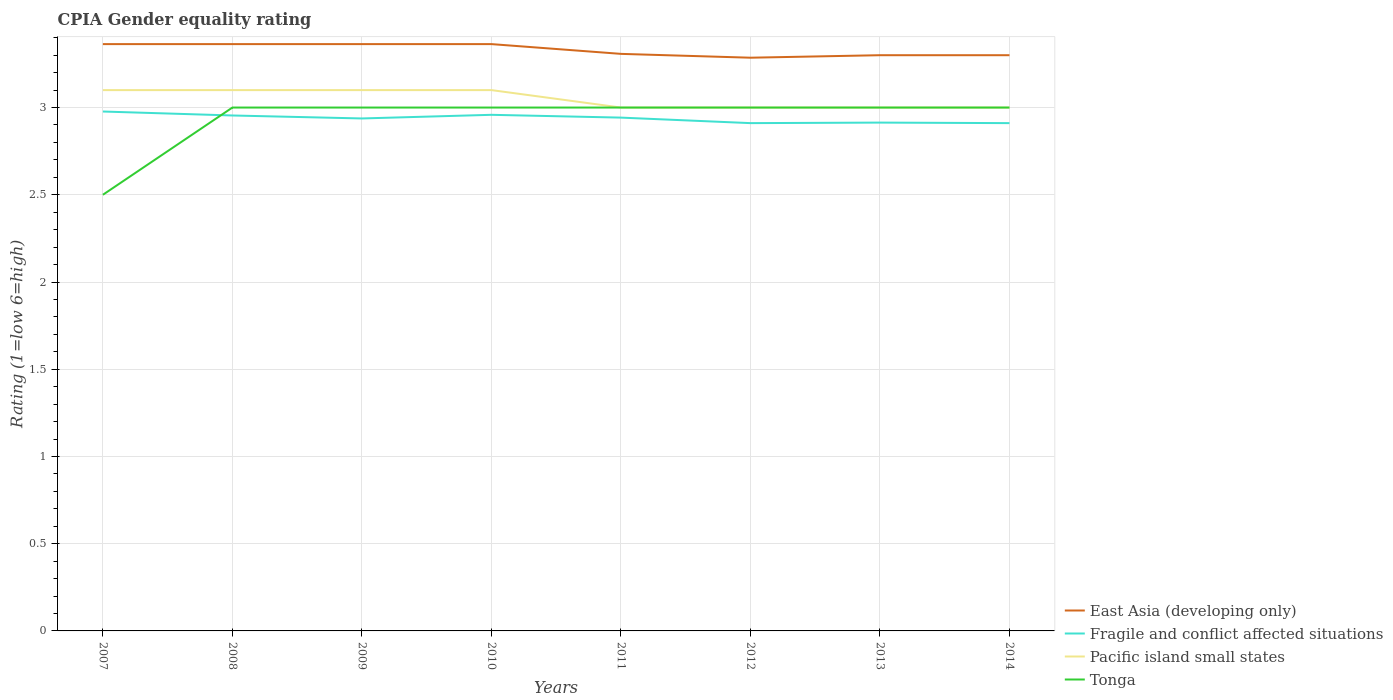How many different coloured lines are there?
Keep it short and to the point. 4. Does the line corresponding to Fragile and conflict affected situations intersect with the line corresponding to East Asia (developing only)?
Your response must be concise. No. Is the number of lines equal to the number of legend labels?
Keep it short and to the point. Yes. Across all years, what is the maximum CPIA rating in Fragile and conflict affected situations?
Give a very brief answer. 2.91. In which year was the CPIA rating in Fragile and conflict affected situations maximum?
Provide a short and direct response. 2012. What is the total CPIA rating in Fragile and conflict affected situations in the graph?
Ensure brevity in your answer.  0.07. What is the difference between the highest and the second highest CPIA rating in Pacific island small states?
Make the answer very short. 0.1. Is the CPIA rating in Pacific island small states strictly greater than the CPIA rating in Tonga over the years?
Offer a terse response. No. How many years are there in the graph?
Offer a terse response. 8. How many legend labels are there?
Provide a succinct answer. 4. What is the title of the graph?
Your response must be concise. CPIA Gender equality rating. What is the label or title of the Y-axis?
Offer a terse response. Rating (1=low 6=high). What is the Rating (1=low 6=high) of East Asia (developing only) in 2007?
Offer a terse response. 3.36. What is the Rating (1=low 6=high) in Fragile and conflict affected situations in 2007?
Make the answer very short. 2.98. What is the Rating (1=low 6=high) in Tonga in 2007?
Provide a short and direct response. 2.5. What is the Rating (1=low 6=high) of East Asia (developing only) in 2008?
Offer a very short reply. 3.36. What is the Rating (1=low 6=high) in Fragile and conflict affected situations in 2008?
Your response must be concise. 2.95. What is the Rating (1=low 6=high) in Pacific island small states in 2008?
Ensure brevity in your answer.  3.1. What is the Rating (1=low 6=high) of East Asia (developing only) in 2009?
Make the answer very short. 3.36. What is the Rating (1=low 6=high) of Fragile and conflict affected situations in 2009?
Keep it short and to the point. 2.94. What is the Rating (1=low 6=high) of Pacific island small states in 2009?
Ensure brevity in your answer.  3.1. What is the Rating (1=low 6=high) of Tonga in 2009?
Give a very brief answer. 3. What is the Rating (1=low 6=high) of East Asia (developing only) in 2010?
Provide a succinct answer. 3.36. What is the Rating (1=low 6=high) in Fragile and conflict affected situations in 2010?
Make the answer very short. 2.96. What is the Rating (1=low 6=high) in East Asia (developing only) in 2011?
Give a very brief answer. 3.31. What is the Rating (1=low 6=high) of Fragile and conflict affected situations in 2011?
Provide a short and direct response. 2.94. What is the Rating (1=low 6=high) of East Asia (developing only) in 2012?
Ensure brevity in your answer.  3.29. What is the Rating (1=low 6=high) in Fragile and conflict affected situations in 2012?
Provide a succinct answer. 2.91. What is the Rating (1=low 6=high) of East Asia (developing only) in 2013?
Offer a very short reply. 3.3. What is the Rating (1=low 6=high) of Fragile and conflict affected situations in 2013?
Ensure brevity in your answer.  2.91. What is the Rating (1=low 6=high) of Pacific island small states in 2013?
Make the answer very short. 3. What is the Rating (1=low 6=high) in East Asia (developing only) in 2014?
Your answer should be very brief. 3.3. What is the Rating (1=low 6=high) of Fragile and conflict affected situations in 2014?
Your answer should be very brief. 2.91. What is the Rating (1=low 6=high) of Pacific island small states in 2014?
Offer a terse response. 3. Across all years, what is the maximum Rating (1=low 6=high) in East Asia (developing only)?
Your answer should be compact. 3.36. Across all years, what is the maximum Rating (1=low 6=high) of Fragile and conflict affected situations?
Keep it short and to the point. 2.98. Across all years, what is the maximum Rating (1=low 6=high) in Pacific island small states?
Make the answer very short. 3.1. Across all years, what is the maximum Rating (1=low 6=high) in Tonga?
Your answer should be very brief. 3. Across all years, what is the minimum Rating (1=low 6=high) in East Asia (developing only)?
Provide a succinct answer. 3.29. Across all years, what is the minimum Rating (1=low 6=high) of Fragile and conflict affected situations?
Give a very brief answer. 2.91. Across all years, what is the minimum Rating (1=low 6=high) in Pacific island small states?
Offer a terse response. 3. What is the total Rating (1=low 6=high) in East Asia (developing only) in the graph?
Provide a short and direct response. 26.65. What is the total Rating (1=low 6=high) of Fragile and conflict affected situations in the graph?
Your answer should be very brief. 23.51. What is the total Rating (1=low 6=high) in Pacific island small states in the graph?
Offer a very short reply. 24.4. What is the difference between the Rating (1=low 6=high) of East Asia (developing only) in 2007 and that in 2008?
Provide a succinct answer. 0. What is the difference between the Rating (1=low 6=high) in Fragile and conflict affected situations in 2007 and that in 2008?
Offer a very short reply. 0.02. What is the difference between the Rating (1=low 6=high) in Tonga in 2007 and that in 2008?
Your answer should be very brief. -0.5. What is the difference between the Rating (1=low 6=high) in East Asia (developing only) in 2007 and that in 2009?
Give a very brief answer. 0. What is the difference between the Rating (1=low 6=high) of Fragile and conflict affected situations in 2007 and that in 2009?
Offer a terse response. 0.04. What is the difference between the Rating (1=low 6=high) of Fragile and conflict affected situations in 2007 and that in 2010?
Provide a short and direct response. 0.02. What is the difference between the Rating (1=low 6=high) in Tonga in 2007 and that in 2010?
Offer a very short reply. -0.5. What is the difference between the Rating (1=low 6=high) in East Asia (developing only) in 2007 and that in 2011?
Make the answer very short. 0.06. What is the difference between the Rating (1=low 6=high) of Fragile and conflict affected situations in 2007 and that in 2011?
Ensure brevity in your answer.  0.04. What is the difference between the Rating (1=low 6=high) in Tonga in 2007 and that in 2011?
Ensure brevity in your answer.  -0.5. What is the difference between the Rating (1=low 6=high) in East Asia (developing only) in 2007 and that in 2012?
Ensure brevity in your answer.  0.08. What is the difference between the Rating (1=low 6=high) of Fragile and conflict affected situations in 2007 and that in 2012?
Your answer should be very brief. 0.07. What is the difference between the Rating (1=low 6=high) of Tonga in 2007 and that in 2012?
Ensure brevity in your answer.  -0.5. What is the difference between the Rating (1=low 6=high) of East Asia (developing only) in 2007 and that in 2013?
Your answer should be very brief. 0.06. What is the difference between the Rating (1=low 6=high) in Fragile and conflict affected situations in 2007 and that in 2013?
Your response must be concise. 0.06. What is the difference between the Rating (1=low 6=high) in Pacific island small states in 2007 and that in 2013?
Offer a very short reply. 0.1. What is the difference between the Rating (1=low 6=high) of East Asia (developing only) in 2007 and that in 2014?
Provide a succinct answer. 0.06. What is the difference between the Rating (1=low 6=high) of Fragile and conflict affected situations in 2007 and that in 2014?
Provide a succinct answer. 0.07. What is the difference between the Rating (1=low 6=high) in Pacific island small states in 2007 and that in 2014?
Offer a terse response. 0.1. What is the difference between the Rating (1=low 6=high) in East Asia (developing only) in 2008 and that in 2009?
Your answer should be compact. 0. What is the difference between the Rating (1=low 6=high) of Fragile and conflict affected situations in 2008 and that in 2009?
Your answer should be compact. 0.02. What is the difference between the Rating (1=low 6=high) in Tonga in 2008 and that in 2009?
Give a very brief answer. 0. What is the difference between the Rating (1=low 6=high) in East Asia (developing only) in 2008 and that in 2010?
Your response must be concise. 0. What is the difference between the Rating (1=low 6=high) of Fragile and conflict affected situations in 2008 and that in 2010?
Offer a very short reply. -0. What is the difference between the Rating (1=low 6=high) in Pacific island small states in 2008 and that in 2010?
Your response must be concise. 0. What is the difference between the Rating (1=low 6=high) in East Asia (developing only) in 2008 and that in 2011?
Keep it short and to the point. 0.06. What is the difference between the Rating (1=low 6=high) of Fragile and conflict affected situations in 2008 and that in 2011?
Your response must be concise. 0.01. What is the difference between the Rating (1=low 6=high) in Tonga in 2008 and that in 2011?
Ensure brevity in your answer.  0. What is the difference between the Rating (1=low 6=high) in East Asia (developing only) in 2008 and that in 2012?
Ensure brevity in your answer.  0.08. What is the difference between the Rating (1=low 6=high) in Fragile and conflict affected situations in 2008 and that in 2012?
Your answer should be very brief. 0.04. What is the difference between the Rating (1=low 6=high) of East Asia (developing only) in 2008 and that in 2013?
Your answer should be compact. 0.06. What is the difference between the Rating (1=low 6=high) of Fragile and conflict affected situations in 2008 and that in 2013?
Your answer should be very brief. 0.04. What is the difference between the Rating (1=low 6=high) in Pacific island small states in 2008 and that in 2013?
Offer a very short reply. 0.1. What is the difference between the Rating (1=low 6=high) of East Asia (developing only) in 2008 and that in 2014?
Ensure brevity in your answer.  0.06. What is the difference between the Rating (1=low 6=high) of Fragile and conflict affected situations in 2008 and that in 2014?
Give a very brief answer. 0.04. What is the difference between the Rating (1=low 6=high) of Pacific island small states in 2008 and that in 2014?
Your answer should be very brief. 0.1. What is the difference between the Rating (1=low 6=high) of Fragile and conflict affected situations in 2009 and that in 2010?
Provide a short and direct response. -0.02. What is the difference between the Rating (1=low 6=high) in Tonga in 2009 and that in 2010?
Your response must be concise. 0. What is the difference between the Rating (1=low 6=high) in East Asia (developing only) in 2009 and that in 2011?
Ensure brevity in your answer.  0.06. What is the difference between the Rating (1=low 6=high) of Fragile and conflict affected situations in 2009 and that in 2011?
Make the answer very short. -0. What is the difference between the Rating (1=low 6=high) of Pacific island small states in 2009 and that in 2011?
Your response must be concise. 0.1. What is the difference between the Rating (1=low 6=high) in Tonga in 2009 and that in 2011?
Your answer should be compact. 0. What is the difference between the Rating (1=low 6=high) in East Asia (developing only) in 2009 and that in 2012?
Your response must be concise. 0.08. What is the difference between the Rating (1=low 6=high) of Fragile and conflict affected situations in 2009 and that in 2012?
Provide a succinct answer. 0.03. What is the difference between the Rating (1=low 6=high) of Tonga in 2009 and that in 2012?
Make the answer very short. 0. What is the difference between the Rating (1=low 6=high) in East Asia (developing only) in 2009 and that in 2013?
Offer a terse response. 0.06. What is the difference between the Rating (1=low 6=high) in Fragile and conflict affected situations in 2009 and that in 2013?
Your answer should be compact. 0.02. What is the difference between the Rating (1=low 6=high) in East Asia (developing only) in 2009 and that in 2014?
Ensure brevity in your answer.  0.06. What is the difference between the Rating (1=low 6=high) of Fragile and conflict affected situations in 2009 and that in 2014?
Make the answer very short. 0.03. What is the difference between the Rating (1=low 6=high) of Tonga in 2009 and that in 2014?
Ensure brevity in your answer.  0. What is the difference between the Rating (1=low 6=high) of East Asia (developing only) in 2010 and that in 2011?
Your answer should be compact. 0.06. What is the difference between the Rating (1=low 6=high) in Fragile and conflict affected situations in 2010 and that in 2011?
Offer a terse response. 0.02. What is the difference between the Rating (1=low 6=high) in Pacific island small states in 2010 and that in 2011?
Provide a short and direct response. 0.1. What is the difference between the Rating (1=low 6=high) of Tonga in 2010 and that in 2011?
Your response must be concise. 0. What is the difference between the Rating (1=low 6=high) of East Asia (developing only) in 2010 and that in 2012?
Offer a very short reply. 0.08. What is the difference between the Rating (1=low 6=high) in Fragile and conflict affected situations in 2010 and that in 2012?
Your answer should be very brief. 0.05. What is the difference between the Rating (1=low 6=high) of Tonga in 2010 and that in 2012?
Give a very brief answer. 0. What is the difference between the Rating (1=low 6=high) of East Asia (developing only) in 2010 and that in 2013?
Provide a short and direct response. 0.06. What is the difference between the Rating (1=low 6=high) of Fragile and conflict affected situations in 2010 and that in 2013?
Your answer should be very brief. 0.04. What is the difference between the Rating (1=low 6=high) in East Asia (developing only) in 2010 and that in 2014?
Your response must be concise. 0.06. What is the difference between the Rating (1=low 6=high) in Fragile and conflict affected situations in 2010 and that in 2014?
Offer a terse response. 0.05. What is the difference between the Rating (1=low 6=high) in Pacific island small states in 2010 and that in 2014?
Offer a terse response. 0.1. What is the difference between the Rating (1=low 6=high) of Tonga in 2010 and that in 2014?
Your answer should be compact. 0. What is the difference between the Rating (1=low 6=high) in East Asia (developing only) in 2011 and that in 2012?
Your response must be concise. 0.02. What is the difference between the Rating (1=low 6=high) of Fragile and conflict affected situations in 2011 and that in 2012?
Ensure brevity in your answer.  0.03. What is the difference between the Rating (1=low 6=high) of Pacific island small states in 2011 and that in 2012?
Your answer should be compact. 0. What is the difference between the Rating (1=low 6=high) in Tonga in 2011 and that in 2012?
Offer a terse response. 0. What is the difference between the Rating (1=low 6=high) in East Asia (developing only) in 2011 and that in 2013?
Provide a short and direct response. 0.01. What is the difference between the Rating (1=low 6=high) in Fragile and conflict affected situations in 2011 and that in 2013?
Your answer should be very brief. 0.03. What is the difference between the Rating (1=low 6=high) in Pacific island small states in 2011 and that in 2013?
Your response must be concise. 0. What is the difference between the Rating (1=low 6=high) of East Asia (developing only) in 2011 and that in 2014?
Provide a short and direct response. 0.01. What is the difference between the Rating (1=low 6=high) in Fragile and conflict affected situations in 2011 and that in 2014?
Make the answer very short. 0.03. What is the difference between the Rating (1=low 6=high) in East Asia (developing only) in 2012 and that in 2013?
Keep it short and to the point. -0.01. What is the difference between the Rating (1=low 6=high) in Fragile and conflict affected situations in 2012 and that in 2013?
Keep it short and to the point. -0. What is the difference between the Rating (1=low 6=high) in Pacific island small states in 2012 and that in 2013?
Your response must be concise. 0. What is the difference between the Rating (1=low 6=high) of East Asia (developing only) in 2012 and that in 2014?
Provide a short and direct response. -0.01. What is the difference between the Rating (1=low 6=high) in Fragile and conflict affected situations in 2012 and that in 2014?
Your response must be concise. 0. What is the difference between the Rating (1=low 6=high) of Pacific island small states in 2012 and that in 2014?
Your response must be concise. 0. What is the difference between the Rating (1=low 6=high) of Fragile and conflict affected situations in 2013 and that in 2014?
Your answer should be compact. 0. What is the difference between the Rating (1=low 6=high) in Tonga in 2013 and that in 2014?
Keep it short and to the point. 0. What is the difference between the Rating (1=low 6=high) in East Asia (developing only) in 2007 and the Rating (1=low 6=high) in Fragile and conflict affected situations in 2008?
Offer a very short reply. 0.41. What is the difference between the Rating (1=low 6=high) of East Asia (developing only) in 2007 and the Rating (1=low 6=high) of Pacific island small states in 2008?
Your answer should be compact. 0.26. What is the difference between the Rating (1=low 6=high) in East Asia (developing only) in 2007 and the Rating (1=low 6=high) in Tonga in 2008?
Offer a terse response. 0.36. What is the difference between the Rating (1=low 6=high) of Fragile and conflict affected situations in 2007 and the Rating (1=low 6=high) of Pacific island small states in 2008?
Give a very brief answer. -0.12. What is the difference between the Rating (1=low 6=high) of Fragile and conflict affected situations in 2007 and the Rating (1=low 6=high) of Tonga in 2008?
Ensure brevity in your answer.  -0.02. What is the difference between the Rating (1=low 6=high) in East Asia (developing only) in 2007 and the Rating (1=low 6=high) in Fragile and conflict affected situations in 2009?
Provide a short and direct response. 0.43. What is the difference between the Rating (1=low 6=high) in East Asia (developing only) in 2007 and the Rating (1=low 6=high) in Pacific island small states in 2009?
Offer a terse response. 0.26. What is the difference between the Rating (1=low 6=high) in East Asia (developing only) in 2007 and the Rating (1=low 6=high) in Tonga in 2009?
Provide a short and direct response. 0.36. What is the difference between the Rating (1=low 6=high) in Fragile and conflict affected situations in 2007 and the Rating (1=low 6=high) in Pacific island small states in 2009?
Offer a terse response. -0.12. What is the difference between the Rating (1=low 6=high) in Fragile and conflict affected situations in 2007 and the Rating (1=low 6=high) in Tonga in 2009?
Make the answer very short. -0.02. What is the difference between the Rating (1=low 6=high) of East Asia (developing only) in 2007 and the Rating (1=low 6=high) of Fragile and conflict affected situations in 2010?
Give a very brief answer. 0.41. What is the difference between the Rating (1=low 6=high) in East Asia (developing only) in 2007 and the Rating (1=low 6=high) in Pacific island small states in 2010?
Your response must be concise. 0.26. What is the difference between the Rating (1=low 6=high) of East Asia (developing only) in 2007 and the Rating (1=low 6=high) of Tonga in 2010?
Keep it short and to the point. 0.36. What is the difference between the Rating (1=low 6=high) of Fragile and conflict affected situations in 2007 and the Rating (1=low 6=high) of Pacific island small states in 2010?
Make the answer very short. -0.12. What is the difference between the Rating (1=low 6=high) of Fragile and conflict affected situations in 2007 and the Rating (1=low 6=high) of Tonga in 2010?
Provide a short and direct response. -0.02. What is the difference between the Rating (1=low 6=high) in East Asia (developing only) in 2007 and the Rating (1=low 6=high) in Fragile and conflict affected situations in 2011?
Your response must be concise. 0.42. What is the difference between the Rating (1=low 6=high) of East Asia (developing only) in 2007 and the Rating (1=low 6=high) of Pacific island small states in 2011?
Ensure brevity in your answer.  0.36. What is the difference between the Rating (1=low 6=high) in East Asia (developing only) in 2007 and the Rating (1=low 6=high) in Tonga in 2011?
Offer a very short reply. 0.36. What is the difference between the Rating (1=low 6=high) of Fragile and conflict affected situations in 2007 and the Rating (1=low 6=high) of Pacific island small states in 2011?
Offer a terse response. -0.02. What is the difference between the Rating (1=low 6=high) in Fragile and conflict affected situations in 2007 and the Rating (1=low 6=high) in Tonga in 2011?
Give a very brief answer. -0.02. What is the difference between the Rating (1=low 6=high) of Pacific island small states in 2007 and the Rating (1=low 6=high) of Tonga in 2011?
Offer a terse response. 0.1. What is the difference between the Rating (1=low 6=high) of East Asia (developing only) in 2007 and the Rating (1=low 6=high) of Fragile and conflict affected situations in 2012?
Make the answer very short. 0.45. What is the difference between the Rating (1=low 6=high) in East Asia (developing only) in 2007 and the Rating (1=low 6=high) in Pacific island small states in 2012?
Offer a terse response. 0.36. What is the difference between the Rating (1=low 6=high) of East Asia (developing only) in 2007 and the Rating (1=low 6=high) of Tonga in 2012?
Keep it short and to the point. 0.36. What is the difference between the Rating (1=low 6=high) of Fragile and conflict affected situations in 2007 and the Rating (1=low 6=high) of Pacific island small states in 2012?
Offer a very short reply. -0.02. What is the difference between the Rating (1=low 6=high) of Fragile and conflict affected situations in 2007 and the Rating (1=low 6=high) of Tonga in 2012?
Keep it short and to the point. -0.02. What is the difference between the Rating (1=low 6=high) of Pacific island small states in 2007 and the Rating (1=low 6=high) of Tonga in 2012?
Your answer should be very brief. 0.1. What is the difference between the Rating (1=low 6=high) in East Asia (developing only) in 2007 and the Rating (1=low 6=high) in Fragile and conflict affected situations in 2013?
Ensure brevity in your answer.  0.45. What is the difference between the Rating (1=low 6=high) of East Asia (developing only) in 2007 and the Rating (1=low 6=high) of Pacific island small states in 2013?
Make the answer very short. 0.36. What is the difference between the Rating (1=low 6=high) of East Asia (developing only) in 2007 and the Rating (1=low 6=high) of Tonga in 2013?
Offer a very short reply. 0.36. What is the difference between the Rating (1=low 6=high) in Fragile and conflict affected situations in 2007 and the Rating (1=low 6=high) in Pacific island small states in 2013?
Provide a succinct answer. -0.02. What is the difference between the Rating (1=low 6=high) in Fragile and conflict affected situations in 2007 and the Rating (1=low 6=high) in Tonga in 2013?
Provide a short and direct response. -0.02. What is the difference between the Rating (1=low 6=high) in Pacific island small states in 2007 and the Rating (1=low 6=high) in Tonga in 2013?
Your answer should be compact. 0.1. What is the difference between the Rating (1=low 6=high) of East Asia (developing only) in 2007 and the Rating (1=low 6=high) of Fragile and conflict affected situations in 2014?
Offer a very short reply. 0.45. What is the difference between the Rating (1=low 6=high) in East Asia (developing only) in 2007 and the Rating (1=low 6=high) in Pacific island small states in 2014?
Your answer should be compact. 0.36. What is the difference between the Rating (1=low 6=high) of East Asia (developing only) in 2007 and the Rating (1=low 6=high) of Tonga in 2014?
Offer a terse response. 0.36. What is the difference between the Rating (1=low 6=high) of Fragile and conflict affected situations in 2007 and the Rating (1=low 6=high) of Pacific island small states in 2014?
Make the answer very short. -0.02. What is the difference between the Rating (1=low 6=high) in Fragile and conflict affected situations in 2007 and the Rating (1=low 6=high) in Tonga in 2014?
Offer a terse response. -0.02. What is the difference between the Rating (1=low 6=high) in Pacific island small states in 2007 and the Rating (1=low 6=high) in Tonga in 2014?
Make the answer very short. 0.1. What is the difference between the Rating (1=low 6=high) of East Asia (developing only) in 2008 and the Rating (1=low 6=high) of Fragile and conflict affected situations in 2009?
Provide a short and direct response. 0.43. What is the difference between the Rating (1=low 6=high) in East Asia (developing only) in 2008 and the Rating (1=low 6=high) in Pacific island small states in 2009?
Your answer should be compact. 0.26. What is the difference between the Rating (1=low 6=high) in East Asia (developing only) in 2008 and the Rating (1=low 6=high) in Tonga in 2009?
Ensure brevity in your answer.  0.36. What is the difference between the Rating (1=low 6=high) in Fragile and conflict affected situations in 2008 and the Rating (1=low 6=high) in Pacific island small states in 2009?
Your answer should be very brief. -0.15. What is the difference between the Rating (1=low 6=high) in Fragile and conflict affected situations in 2008 and the Rating (1=low 6=high) in Tonga in 2009?
Your response must be concise. -0.05. What is the difference between the Rating (1=low 6=high) in East Asia (developing only) in 2008 and the Rating (1=low 6=high) in Fragile and conflict affected situations in 2010?
Give a very brief answer. 0.41. What is the difference between the Rating (1=low 6=high) in East Asia (developing only) in 2008 and the Rating (1=low 6=high) in Pacific island small states in 2010?
Provide a succinct answer. 0.26. What is the difference between the Rating (1=low 6=high) in East Asia (developing only) in 2008 and the Rating (1=low 6=high) in Tonga in 2010?
Offer a terse response. 0.36. What is the difference between the Rating (1=low 6=high) of Fragile and conflict affected situations in 2008 and the Rating (1=low 6=high) of Pacific island small states in 2010?
Offer a very short reply. -0.15. What is the difference between the Rating (1=low 6=high) in Fragile and conflict affected situations in 2008 and the Rating (1=low 6=high) in Tonga in 2010?
Your answer should be compact. -0.05. What is the difference between the Rating (1=low 6=high) of East Asia (developing only) in 2008 and the Rating (1=low 6=high) of Fragile and conflict affected situations in 2011?
Offer a terse response. 0.42. What is the difference between the Rating (1=low 6=high) of East Asia (developing only) in 2008 and the Rating (1=low 6=high) of Pacific island small states in 2011?
Your answer should be compact. 0.36. What is the difference between the Rating (1=low 6=high) in East Asia (developing only) in 2008 and the Rating (1=low 6=high) in Tonga in 2011?
Make the answer very short. 0.36. What is the difference between the Rating (1=low 6=high) in Fragile and conflict affected situations in 2008 and the Rating (1=low 6=high) in Pacific island small states in 2011?
Make the answer very short. -0.05. What is the difference between the Rating (1=low 6=high) of Fragile and conflict affected situations in 2008 and the Rating (1=low 6=high) of Tonga in 2011?
Give a very brief answer. -0.05. What is the difference between the Rating (1=low 6=high) in East Asia (developing only) in 2008 and the Rating (1=low 6=high) in Fragile and conflict affected situations in 2012?
Make the answer very short. 0.45. What is the difference between the Rating (1=low 6=high) in East Asia (developing only) in 2008 and the Rating (1=low 6=high) in Pacific island small states in 2012?
Offer a very short reply. 0.36. What is the difference between the Rating (1=low 6=high) in East Asia (developing only) in 2008 and the Rating (1=low 6=high) in Tonga in 2012?
Ensure brevity in your answer.  0.36. What is the difference between the Rating (1=low 6=high) in Fragile and conflict affected situations in 2008 and the Rating (1=low 6=high) in Pacific island small states in 2012?
Your answer should be compact. -0.05. What is the difference between the Rating (1=low 6=high) of Fragile and conflict affected situations in 2008 and the Rating (1=low 6=high) of Tonga in 2012?
Your response must be concise. -0.05. What is the difference between the Rating (1=low 6=high) of Pacific island small states in 2008 and the Rating (1=low 6=high) of Tonga in 2012?
Offer a very short reply. 0.1. What is the difference between the Rating (1=low 6=high) of East Asia (developing only) in 2008 and the Rating (1=low 6=high) of Fragile and conflict affected situations in 2013?
Give a very brief answer. 0.45. What is the difference between the Rating (1=low 6=high) of East Asia (developing only) in 2008 and the Rating (1=low 6=high) of Pacific island small states in 2013?
Make the answer very short. 0.36. What is the difference between the Rating (1=low 6=high) of East Asia (developing only) in 2008 and the Rating (1=low 6=high) of Tonga in 2013?
Your answer should be very brief. 0.36. What is the difference between the Rating (1=low 6=high) of Fragile and conflict affected situations in 2008 and the Rating (1=low 6=high) of Pacific island small states in 2013?
Your response must be concise. -0.05. What is the difference between the Rating (1=low 6=high) in Fragile and conflict affected situations in 2008 and the Rating (1=low 6=high) in Tonga in 2013?
Provide a succinct answer. -0.05. What is the difference between the Rating (1=low 6=high) of East Asia (developing only) in 2008 and the Rating (1=low 6=high) of Fragile and conflict affected situations in 2014?
Offer a very short reply. 0.45. What is the difference between the Rating (1=low 6=high) of East Asia (developing only) in 2008 and the Rating (1=low 6=high) of Pacific island small states in 2014?
Your answer should be compact. 0.36. What is the difference between the Rating (1=low 6=high) in East Asia (developing only) in 2008 and the Rating (1=low 6=high) in Tonga in 2014?
Offer a very short reply. 0.36. What is the difference between the Rating (1=low 6=high) in Fragile and conflict affected situations in 2008 and the Rating (1=low 6=high) in Pacific island small states in 2014?
Offer a very short reply. -0.05. What is the difference between the Rating (1=low 6=high) of Fragile and conflict affected situations in 2008 and the Rating (1=low 6=high) of Tonga in 2014?
Ensure brevity in your answer.  -0.05. What is the difference between the Rating (1=low 6=high) in Pacific island small states in 2008 and the Rating (1=low 6=high) in Tonga in 2014?
Make the answer very short. 0.1. What is the difference between the Rating (1=low 6=high) of East Asia (developing only) in 2009 and the Rating (1=low 6=high) of Fragile and conflict affected situations in 2010?
Provide a succinct answer. 0.41. What is the difference between the Rating (1=low 6=high) in East Asia (developing only) in 2009 and the Rating (1=low 6=high) in Pacific island small states in 2010?
Ensure brevity in your answer.  0.26. What is the difference between the Rating (1=low 6=high) of East Asia (developing only) in 2009 and the Rating (1=low 6=high) of Tonga in 2010?
Keep it short and to the point. 0.36. What is the difference between the Rating (1=low 6=high) of Fragile and conflict affected situations in 2009 and the Rating (1=low 6=high) of Pacific island small states in 2010?
Keep it short and to the point. -0.16. What is the difference between the Rating (1=low 6=high) in Fragile and conflict affected situations in 2009 and the Rating (1=low 6=high) in Tonga in 2010?
Your response must be concise. -0.06. What is the difference between the Rating (1=low 6=high) in East Asia (developing only) in 2009 and the Rating (1=low 6=high) in Fragile and conflict affected situations in 2011?
Provide a short and direct response. 0.42. What is the difference between the Rating (1=low 6=high) of East Asia (developing only) in 2009 and the Rating (1=low 6=high) of Pacific island small states in 2011?
Give a very brief answer. 0.36. What is the difference between the Rating (1=low 6=high) of East Asia (developing only) in 2009 and the Rating (1=low 6=high) of Tonga in 2011?
Your response must be concise. 0.36. What is the difference between the Rating (1=low 6=high) in Fragile and conflict affected situations in 2009 and the Rating (1=low 6=high) in Pacific island small states in 2011?
Provide a succinct answer. -0.06. What is the difference between the Rating (1=low 6=high) in Fragile and conflict affected situations in 2009 and the Rating (1=low 6=high) in Tonga in 2011?
Ensure brevity in your answer.  -0.06. What is the difference between the Rating (1=low 6=high) in East Asia (developing only) in 2009 and the Rating (1=low 6=high) in Fragile and conflict affected situations in 2012?
Provide a succinct answer. 0.45. What is the difference between the Rating (1=low 6=high) in East Asia (developing only) in 2009 and the Rating (1=low 6=high) in Pacific island small states in 2012?
Provide a succinct answer. 0.36. What is the difference between the Rating (1=low 6=high) in East Asia (developing only) in 2009 and the Rating (1=low 6=high) in Tonga in 2012?
Provide a succinct answer. 0.36. What is the difference between the Rating (1=low 6=high) of Fragile and conflict affected situations in 2009 and the Rating (1=low 6=high) of Pacific island small states in 2012?
Your answer should be very brief. -0.06. What is the difference between the Rating (1=low 6=high) in Fragile and conflict affected situations in 2009 and the Rating (1=low 6=high) in Tonga in 2012?
Make the answer very short. -0.06. What is the difference between the Rating (1=low 6=high) in East Asia (developing only) in 2009 and the Rating (1=low 6=high) in Fragile and conflict affected situations in 2013?
Give a very brief answer. 0.45. What is the difference between the Rating (1=low 6=high) of East Asia (developing only) in 2009 and the Rating (1=low 6=high) of Pacific island small states in 2013?
Offer a very short reply. 0.36. What is the difference between the Rating (1=low 6=high) in East Asia (developing only) in 2009 and the Rating (1=low 6=high) in Tonga in 2013?
Your answer should be very brief. 0.36. What is the difference between the Rating (1=low 6=high) of Fragile and conflict affected situations in 2009 and the Rating (1=low 6=high) of Pacific island small states in 2013?
Make the answer very short. -0.06. What is the difference between the Rating (1=low 6=high) in Fragile and conflict affected situations in 2009 and the Rating (1=low 6=high) in Tonga in 2013?
Offer a very short reply. -0.06. What is the difference between the Rating (1=low 6=high) in Pacific island small states in 2009 and the Rating (1=low 6=high) in Tonga in 2013?
Keep it short and to the point. 0.1. What is the difference between the Rating (1=low 6=high) of East Asia (developing only) in 2009 and the Rating (1=low 6=high) of Fragile and conflict affected situations in 2014?
Keep it short and to the point. 0.45. What is the difference between the Rating (1=low 6=high) of East Asia (developing only) in 2009 and the Rating (1=low 6=high) of Pacific island small states in 2014?
Provide a succinct answer. 0.36. What is the difference between the Rating (1=low 6=high) of East Asia (developing only) in 2009 and the Rating (1=low 6=high) of Tonga in 2014?
Your answer should be very brief. 0.36. What is the difference between the Rating (1=low 6=high) in Fragile and conflict affected situations in 2009 and the Rating (1=low 6=high) in Pacific island small states in 2014?
Offer a very short reply. -0.06. What is the difference between the Rating (1=low 6=high) in Fragile and conflict affected situations in 2009 and the Rating (1=low 6=high) in Tonga in 2014?
Ensure brevity in your answer.  -0.06. What is the difference between the Rating (1=low 6=high) of East Asia (developing only) in 2010 and the Rating (1=low 6=high) of Fragile and conflict affected situations in 2011?
Provide a short and direct response. 0.42. What is the difference between the Rating (1=low 6=high) in East Asia (developing only) in 2010 and the Rating (1=low 6=high) in Pacific island small states in 2011?
Your response must be concise. 0.36. What is the difference between the Rating (1=low 6=high) in East Asia (developing only) in 2010 and the Rating (1=low 6=high) in Tonga in 2011?
Provide a succinct answer. 0.36. What is the difference between the Rating (1=low 6=high) in Fragile and conflict affected situations in 2010 and the Rating (1=low 6=high) in Pacific island small states in 2011?
Offer a terse response. -0.04. What is the difference between the Rating (1=low 6=high) of Fragile and conflict affected situations in 2010 and the Rating (1=low 6=high) of Tonga in 2011?
Provide a short and direct response. -0.04. What is the difference between the Rating (1=low 6=high) of East Asia (developing only) in 2010 and the Rating (1=low 6=high) of Fragile and conflict affected situations in 2012?
Offer a terse response. 0.45. What is the difference between the Rating (1=low 6=high) in East Asia (developing only) in 2010 and the Rating (1=low 6=high) in Pacific island small states in 2012?
Provide a short and direct response. 0.36. What is the difference between the Rating (1=low 6=high) of East Asia (developing only) in 2010 and the Rating (1=low 6=high) of Tonga in 2012?
Offer a very short reply. 0.36. What is the difference between the Rating (1=low 6=high) of Fragile and conflict affected situations in 2010 and the Rating (1=low 6=high) of Pacific island small states in 2012?
Your answer should be very brief. -0.04. What is the difference between the Rating (1=low 6=high) of Fragile and conflict affected situations in 2010 and the Rating (1=low 6=high) of Tonga in 2012?
Ensure brevity in your answer.  -0.04. What is the difference between the Rating (1=low 6=high) of Pacific island small states in 2010 and the Rating (1=low 6=high) of Tonga in 2012?
Make the answer very short. 0.1. What is the difference between the Rating (1=low 6=high) of East Asia (developing only) in 2010 and the Rating (1=low 6=high) of Fragile and conflict affected situations in 2013?
Offer a very short reply. 0.45. What is the difference between the Rating (1=low 6=high) in East Asia (developing only) in 2010 and the Rating (1=low 6=high) in Pacific island small states in 2013?
Provide a short and direct response. 0.36. What is the difference between the Rating (1=low 6=high) of East Asia (developing only) in 2010 and the Rating (1=low 6=high) of Tonga in 2013?
Provide a succinct answer. 0.36. What is the difference between the Rating (1=low 6=high) of Fragile and conflict affected situations in 2010 and the Rating (1=low 6=high) of Pacific island small states in 2013?
Ensure brevity in your answer.  -0.04. What is the difference between the Rating (1=low 6=high) of Fragile and conflict affected situations in 2010 and the Rating (1=low 6=high) of Tonga in 2013?
Give a very brief answer. -0.04. What is the difference between the Rating (1=low 6=high) in Pacific island small states in 2010 and the Rating (1=low 6=high) in Tonga in 2013?
Offer a terse response. 0.1. What is the difference between the Rating (1=low 6=high) of East Asia (developing only) in 2010 and the Rating (1=low 6=high) of Fragile and conflict affected situations in 2014?
Provide a succinct answer. 0.45. What is the difference between the Rating (1=low 6=high) in East Asia (developing only) in 2010 and the Rating (1=low 6=high) in Pacific island small states in 2014?
Offer a terse response. 0.36. What is the difference between the Rating (1=low 6=high) of East Asia (developing only) in 2010 and the Rating (1=low 6=high) of Tonga in 2014?
Your answer should be very brief. 0.36. What is the difference between the Rating (1=low 6=high) of Fragile and conflict affected situations in 2010 and the Rating (1=low 6=high) of Pacific island small states in 2014?
Provide a short and direct response. -0.04. What is the difference between the Rating (1=low 6=high) in Fragile and conflict affected situations in 2010 and the Rating (1=low 6=high) in Tonga in 2014?
Ensure brevity in your answer.  -0.04. What is the difference between the Rating (1=low 6=high) of Pacific island small states in 2010 and the Rating (1=low 6=high) of Tonga in 2014?
Offer a very short reply. 0.1. What is the difference between the Rating (1=low 6=high) of East Asia (developing only) in 2011 and the Rating (1=low 6=high) of Fragile and conflict affected situations in 2012?
Offer a very short reply. 0.4. What is the difference between the Rating (1=low 6=high) of East Asia (developing only) in 2011 and the Rating (1=low 6=high) of Pacific island small states in 2012?
Make the answer very short. 0.31. What is the difference between the Rating (1=low 6=high) in East Asia (developing only) in 2011 and the Rating (1=low 6=high) in Tonga in 2012?
Provide a succinct answer. 0.31. What is the difference between the Rating (1=low 6=high) in Fragile and conflict affected situations in 2011 and the Rating (1=low 6=high) in Pacific island small states in 2012?
Make the answer very short. -0.06. What is the difference between the Rating (1=low 6=high) of Fragile and conflict affected situations in 2011 and the Rating (1=low 6=high) of Tonga in 2012?
Keep it short and to the point. -0.06. What is the difference between the Rating (1=low 6=high) in Pacific island small states in 2011 and the Rating (1=low 6=high) in Tonga in 2012?
Your answer should be very brief. 0. What is the difference between the Rating (1=low 6=high) of East Asia (developing only) in 2011 and the Rating (1=low 6=high) of Fragile and conflict affected situations in 2013?
Provide a succinct answer. 0.39. What is the difference between the Rating (1=low 6=high) in East Asia (developing only) in 2011 and the Rating (1=low 6=high) in Pacific island small states in 2013?
Your answer should be very brief. 0.31. What is the difference between the Rating (1=low 6=high) in East Asia (developing only) in 2011 and the Rating (1=low 6=high) in Tonga in 2013?
Ensure brevity in your answer.  0.31. What is the difference between the Rating (1=low 6=high) of Fragile and conflict affected situations in 2011 and the Rating (1=low 6=high) of Pacific island small states in 2013?
Keep it short and to the point. -0.06. What is the difference between the Rating (1=low 6=high) of Fragile and conflict affected situations in 2011 and the Rating (1=low 6=high) of Tonga in 2013?
Ensure brevity in your answer.  -0.06. What is the difference between the Rating (1=low 6=high) in East Asia (developing only) in 2011 and the Rating (1=low 6=high) in Fragile and conflict affected situations in 2014?
Offer a terse response. 0.4. What is the difference between the Rating (1=low 6=high) in East Asia (developing only) in 2011 and the Rating (1=low 6=high) in Pacific island small states in 2014?
Your answer should be compact. 0.31. What is the difference between the Rating (1=low 6=high) in East Asia (developing only) in 2011 and the Rating (1=low 6=high) in Tonga in 2014?
Give a very brief answer. 0.31. What is the difference between the Rating (1=low 6=high) in Fragile and conflict affected situations in 2011 and the Rating (1=low 6=high) in Pacific island small states in 2014?
Keep it short and to the point. -0.06. What is the difference between the Rating (1=low 6=high) in Fragile and conflict affected situations in 2011 and the Rating (1=low 6=high) in Tonga in 2014?
Your answer should be compact. -0.06. What is the difference between the Rating (1=low 6=high) in Pacific island small states in 2011 and the Rating (1=low 6=high) in Tonga in 2014?
Keep it short and to the point. 0. What is the difference between the Rating (1=low 6=high) of East Asia (developing only) in 2012 and the Rating (1=low 6=high) of Fragile and conflict affected situations in 2013?
Offer a terse response. 0.37. What is the difference between the Rating (1=low 6=high) in East Asia (developing only) in 2012 and the Rating (1=low 6=high) in Pacific island small states in 2013?
Your answer should be very brief. 0.29. What is the difference between the Rating (1=low 6=high) of East Asia (developing only) in 2012 and the Rating (1=low 6=high) of Tonga in 2013?
Provide a short and direct response. 0.29. What is the difference between the Rating (1=low 6=high) of Fragile and conflict affected situations in 2012 and the Rating (1=low 6=high) of Pacific island small states in 2013?
Your response must be concise. -0.09. What is the difference between the Rating (1=low 6=high) of Fragile and conflict affected situations in 2012 and the Rating (1=low 6=high) of Tonga in 2013?
Your response must be concise. -0.09. What is the difference between the Rating (1=low 6=high) of East Asia (developing only) in 2012 and the Rating (1=low 6=high) of Pacific island small states in 2014?
Your answer should be compact. 0.29. What is the difference between the Rating (1=low 6=high) in East Asia (developing only) in 2012 and the Rating (1=low 6=high) in Tonga in 2014?
Your response must be concise. 0.29. What is the difference between the Rating (1=low 6=high) in Fragile and conflict affected situations in 2012 and the Rating (1=low 6=high) in Pacific island small states in 2014?
Keep it short and to the point. -0.09. What is the difference between the Rating (1=low 6=high) in Fragile and conflict affected situations in 2012 and the Rating (1=low 6=high) in Tonga in 2014?
Offer a terse response. -0.09. What is the difference between the Rating (1=low 6=high) of Pacific island small states in 2012 and the Rating (1=low 6=high) of Tonga in 2014?
Ensure brevity in your answer.  0. What is the difference between the Rating (1=low 6=high) in East Asia (developing only) in 2013 and the Rating (1=low 6=high) in Fragile and conflict affected situations in 2014?
Your response must be concise. 0.39. What is the difference between the Rating (1=low 6=high) of East Asia (developing only) in 2013 and the Rating (1=low 6=high) of Pacific island small states in 2014?
Give a very brief answer. 0.3. What is the difference between the Rating (1=low 6=high) of East Asia (developing only) in 2013 and the Rating (1=low 6=high) of Tonga in 2014?
Offer a very short reply. 0.3. What is the difference between the Rating (1=low 6=high) of Fragile and conflict affected situations in 2013 and the Rating (1=low 6=high) of Pacific island small states in 2014?
Ensure brevity in your answer.  -0.09. What is the difference between the Rating (1=low 6=high) in Fragile and conflict affected situations in 2013 and the Rating (1=low 6=high) in Tonga in 2014?
Make the answer very short. -0.09. What is the difference between the Rating (1=low 6=high) of Pacific island small states in 2013 and the Rating (1=low 6=high) of Tonga in 2014?
Give a very brief answer. 0. What is the average Rating (1=low 6=high) of East Asia (developing only) per year?
Make the answer very short. 3.33. What is the average Rating (1=low 6=high) in Fragile and conflict affected situations per year?
Provide a short and direct response. 2.94. What is the average Rating (1=low 6=high) in Pacific island small states per year?
Your response must be concise. 3.05. What is the average Rating (1=low 6=high) of Tonga per year?
Give a very brief answer. 2.94. In the year 2007, what is the difference between the Rating (1=low 6=high) in East Asia (developing only) and Rating (1=low 6=high) in Fragile and conflict affected situations?
Offer a very short reply. 0.39. In the year 2007, what is the difference between the Rating (1=low 6=high) of East Asia (developing only) and Rating (1=low 6=high) of Pacific island small states?
Your answer should be compact. 0.26. In the year 2007, what is the difference between the Rating (1=low 6=high) of East Asia (developing only) and Rating (1=low 6=high) of Tonga?
Give a very brief answer. 0.86. In the year 2007, what is the difference between the Rating (1=low 6=high) of Fragile and conflict affected situations and Rating (1=low 6=high) of Pacific island small states?
Offer a very short reply. -0.12. In the year 2007, what is the difference between the Rating (1=low 6=high) of Fragile and conflict affected situations and Rating (1=low 6=high) of Tonga?
Ensure brevity in your answer.  0.48. In the year 2008, what is the difference between the Rating (1=low 6=high) in East Asia (developing only) and Rating (1=low 6=high) in Fragile and conflict affected situations?
Offer a terse response. 0.41. In the year 2008, what is the difference between the Rating (1=low 6=high) of East Asia (developing only) and Rating (1=low 6=high) of Pacific island small states?
Ensure brevity in your answer.  0.26. In the year 2008, what is the difference between the Rating (1=low 6=high) of East Asia (developing only) and Rating (1=low 6=high) of Tonga?
Give a very brief answer. 0.36. In the year 2008, what is the difference between the Rating (1=low 6=high) in Fragile and conflict affected situations and Rating (1=low 6=high) in Pacific island small states?
Your answer should be very brief. -0.15. In the year 2008, what is the difference between the Rating (1=low 6=high) in Fragile and conflict affected situations and Rating (1=low 6=high) in Tonga?
Offer a terse response. -0.05. In the year 2008, what is the difference between the Rating (1=low 6=high) in Pacific island small states and Rating (1=low 6=high) in Tonga?
Your response must be concise. 0.1. In the year 2009, what is the difference between the Rating (1=low 6=high) of East Asia (developing only) and Rating (1=low 6=high) of Fragile and conflict affected situations?
Provide a short and direct response. 0.43. In the year 2009, what is the difference between the Rating (1=low 6=high) of East Asia (developing only) and Rating (1=low 6=high) of Pacific island small states?
Your response must be concise. 0.26. In the year 2009, what is the difference between the Rating (1=low 6=high) of East Asia (developing only) and Rating (1=low 6=high) of Tonga?
Your response must be concise. 0.36. In the year 2009, what is the difference between the Rating (1=low 6=high) of Fragile and conflict affected situations and Rating (1=low 6=high) of Pacific island small states?
Give a very brief answer. -0.16. In the year 2009, what is the difference between the Rating (1=low 6=high) in Fragile and conflict affected situations and Rating (1=low 6=high) in Tonga?
Ensure brevity in your answer.  -0.06. In the year 2009, what is the difference between the Rating (1=low 6=high) of Pacific island small states and Rating (1=low 6=high) of Tonga?
Give a very brief answer. 0.1. In the year 2010, what is the difference between the Rating (1=low 6=high) in East Asia (developing only) and Rating (1=low 6=high) in Fragile and conflict affected situations?
Your answer should be compact. 0.41. In the year 2010, what is the difference between the Rating (1=low 6=high) in East Asia (developing only) and Rating (1=low 6=high) in Pacific island small states?
Your answer should be very brief. 0.26. In the year 2010, what is the difference between the Rating (1=low 6=high) in East Asia (developing only) and Rating (1=low 6=high) in Tonga?
Offer a very short reply. 0.36. In the year 2010, what is the difference between the Rating (1=low 6=high) in Fragile and conflict affected situations and Rating (1=low 6=high) in Pacific island small states?
Your answer should be compact. -0.14. In the year 2010, what is the difference between the Rating (1=low 6=high) in Fragile and conflict affected situations and Rating (1=low 6=high) in Tonga?
Offer a terse response. -0.04. In the year 2011, what is the difference between the Rating (1=low 6=high) in East Asia (developing only) and Rating (1=low 6=high) in Fragile and conflict affected situations?
Provide a short and direct response. 0.37. In the year 2011, what is the difference between the Rating (1=low 6=high) of East Asia (developing only) and Rating (1=low 6=high) of Pacific island small states?
Ensure brevity in your answer.  0.31. In the year 2011, what is the difference between the Rating (1=low 6=high) of East Asia (developing only) and Rating (1=low 6=high) of Tonga?
Make the answer very short. 0.31. In the year 2011, what is the difference between the Rating (1=low 6=high) of Fragile and conflict affected situations and Rating (1=low 6=high) of Pacific island small states?
Your response must be concise. -0.06. In the year 2011, what is the difference between the Rating (1=low 6=high) in Fragile and conflict affected situations and Rating (1=low 6=high) in Tonga?
Provide a short and direct response. -0.06. In the year 2011, what is the difference between the Rating (1=low 6=high) of Pacific island small states and Rating (1=low 6=high) of Tonga?
Provide a short and direct response. 0. In the year 2012, what is the difference between the Rating (1=low 6=high) of East Asia (developing only) and Rating (1=low 6=high) of Fragile and conflict affected situations?
Make the answer very short. 0.38. In the year 2012, what is the difference between the Rating (1=low 6=high) in East Asia (developing only) and Rating (1=low 6=high) in Pacific island small states?
Provide a short and direct response. 0.29. In the year 2012, what is the difference between the Rating (1=low 6=high) in East Asia (developing only) and Rating (1=low 6=high) in Tonga?
Ensure brevity in your answer.  0.29. In the year 2012, what is the difference between the Rating (1=low 6=high) in Fragile and conflict affected situations and Rating (1=low 6=high) in Pacific island small states?
Your response must be concise. -0.09. In the year 2012, what is the difference between the Rating (1=low 6=high) in Fragile and conflict affected situations and Rating (1=low 6=high) in Tonga?
Your answer should be very brief. -0.09. In the year 2013, what is the difference between the Rating (1=low 6=high) of East Asia (developing only) and Rating (1=low 6=high) of Fragile and conflict affected situations?
Offer a terse response. 0.39. In the year 2013, what is the difference between the Rating (1=low 6=high) of East Asia (developing only) and Rating (1=low 6=high) of Pacific island small states?
Your response must be concise. 0.3. In the year 2013, what is the difference between the Rating (1=low 6=high) of Fragile and conflict affected situations and Rating (1=low 6=high) of Pacific island small states?
Make the answer very short. -0.09. In the year 2013, what is the difference between the Rating (1=low 6=high) in Fragile and conflict affected situations and Rating (1=low 6=high) in Tonga?
Provide a succinct answer. -0.09. In the year 2013, what is the difference between the Rating (1=low 6=high) in Pacific island small states and Rating (1=low 6=high) in Tonga?
Your answer should be compact. 0. In the year 2014, what is the difference between the Rating (1=low 6=high) of East Asia (developing only) and Rating (1=low 6=high) of Fragile and conflict affected situations?
Keep it short and to the point. 0.39. In the year 2014, what is the difference between the Rating (1=low 6=high) in East Asia (developing only) and Rating (1=low 6=high) in Pacific island small states?
Provide a succinct answer. 0.3. In the year 2014, what is the difference between the Rating (1=low 6=high) in Fragile and conflict affected situations and Rating (1=low 6=high) in Pacific island small states?
Keep it short and to the point. -0.09. In the year 2014, what is the difference between the Rating (1=low 6=high) of Fragile and conflict affected situations and Rating (1=low 6=high) of Tonga?
Provide a succinct answer. -0.09. In the year 2014, what is the difference between the Rating (1=low 6=high) in Pacific island small states and Rating (1=low 6=high) in Tonga?
Make the answer very short. 0. What is the ratio of the Rating (1=low 6=high) in Fragile and conflict affected situations in 2007 to that in 2008?
Provide a succinct answer. 1.01. What is the ratio of the Rating (1=low 6=high) in Pacific island small states in 2007 to that in 2008?
Give a very brief answer. 1. What is the ratio of the Rating (1=low 6=high) in East Asia (developing only) in 2007 to that in 2009?
Make the answer very short. 1. What is the ratio of the Rating (1=low 6=high) of Fragile and conflict affected situations in 2007 to that in 2009?
Your answer should be compact. 1.01. What is the ratio of the Rating (1=low 6=high) in Pacific island small states in 2007 to that in 2009?
Offer a terse response. 1. What is the ratio of the Rating (1=low 6=high) in East Asia (developing only) in 2007 to that in 2010?
Provide a succinct answer. 1. What is the ratio of the Rating (1=low 6=high) in Fragile and conflict affected situations in 2007 to that in 2010?
Make the answer very short. 1.01. What is the ratio of the Rating (1=low 6=high) of Pacific island small states in 2007 to that in 2010?
Your response must be concise. 1. What is the ratio of the Rating (1=low 6=high) of East Asia (developing only) in 2007 to that in 2011?
Give a very brief answer. 1.02. What is the ratio of the Rating (1=low 6=high) in Fragile and conflict affected situations in 2007 to that in 2011?
Your answer should be very brief. 1.01. What is the ratio of the Rating (1=low 6=high) in East Asia (developing only) in 2007 to that in 2012?
Your answer should be compact. 1.02. What is the ratio of the Rating (1=low 6=high) in Fragile and conflict affected situations in 2007 to that in 2012?
Ensure brevity in your answer.  1.02. What is the ratio of the Rating (1=low 6=high) of Pacific island small states in 2007 to that in 2012?
Your answer should be compact. 1.03. What is the ratio of the Rating (1=low 6=high) of East Asia (developing only) in 2007 to that in 2013?
Provide a short and direct response. 1.02. What is the ratio of the Rating (1=low 6=high) of Fragile and conflict affected situations in 2007 to that in 2013?
Keep it short and to the point. 1.02. What is the ratio of the Rating (1=low 6=high) of Pacific island small states in 2007 to that in 2013?
Your answer should be compact. 1.03. What is the ratio of the Rating (1=low 6=high) of Tonga in 2007 to that in 2013?
Your response must be concise. 0.83. What is the ratio of the Rating (1=low 6=high) of East Asia (developing only) in 2007 to that in 2014?
Your answer should be compact. 1.02. What is the ratio of the Rating (1=low 6=high) of Fragile and conflict affected situations in 2007 to that in 2014?
Provide a succinct answer. 1.02. What is the ratio of the Rating (1=low 6=high) in Pacific island small states in 2007 to that in 2014?
Your answer should be very brief. 1.03. What is the ratio of the Rating (1=low 6=high) in East Asia (developing only) in 2008 to that in 2009?
Your response must be concise. 1. What is the ratio of the Rating (1=low 6=high) of Fragile and conflict affected situations in 2008 to that in 2009?
Offer a terse response. 1.01. What is the ratio of the Rating (1=low 6=high) of Pacific island small states in 2008 to that in 2009?
Provide a succinct answer. 1. What is the ratio of the Rating (1=low 6=high) in Tonga in 2008 to that in 2009?
Your response must be concise. 1. What is the ratio of the Rating (1=low 6=high) of East Asia (developing only) in 2008 to that in 2010?
Provide a short and direct response. 1. What is the ratio of the Rating (1=low 6=high) of Fragile and conflict affected situations in 2008 to that in 2010?
Your answer should be compact. 1. What is the ratio of the Rating (1=low 6=high) of Pacific island small states in 2008 to that in 2010?
Make the answer very short. 1. What is the ratio of the Rating (1=low 6=high) of Tonga in 2008 to that in 2010?
Your answer should be very brief. 1. What is the ratio of the Rating (1=low 6=high) in East Asia (developing only) in 2008 to that in 2011?
Your response must be concise. 1.02. What is the ratio of the Rating (1=low 6=high) in Pacific island small states in 2008 to that in 2011?
Offer a terse response. 1.03. What is the ratio of the Rating (1=low 6=high) of East Asia (developing only) in 2008 to that in 2012?
Make the answer very short. 1.02. What is the ratio of the Rating (1=low 6=high) in Fragile and conflict affected situations in 2008 to that in 2012?
Ensure brevity in your answer.  1.02. What is the ratio of the Rating (1=low 6=high) in Pacific island small states in 2008 to that in 2012?
Keep it short and to the point. 1.03. What is the ratio of the Rating (1=low 6=high) in Tonga in 2008 to that in 2012?
Provide a short and direct response. 1. What is the ratio of the Rating (1=low 6=high) of East Asia (developing only) in 2008 to that in 2013?
Make the answer very short. 1.02. What is the ratio of the Rating (1=low 6=high) of Fragile and conflict affected situations in 2008 to that in 2013?
Your response must be concise. 1.01. What is the ratio of the Rating (1=low 6=high) of Tonga in 2008 to that in 2013?
Provide a succinct answer. 1. What is the ratio of the Rating (1=low 6=high) of East Asia (developing only) in 2008 to that in 2014?
Give a very brief answer. 1.02. What is the ratio of the Rating (1=low 6=high) in Fragile and conflict affected situations in 2008 to that in 2014?
Offer a very short reply. 1.02. What is the ratio of the Rating (1=low 6=high) in Tonga in 2008 to that in 2014?
Offer a terse response. 1. What is the ratio of the Rating (1=low 6=high) in Fragile and conflict affected situations in 2009 to that in 2010?
Ensure brevity in your answer.  0.99. What is the ratio of the Rating (1=low 6=high) of East Asia (developing only) in 2009 to that in 2011?
Offer a very short reply. 1.02. What is the ratio of the Rating (1=low 6=high) of Tonga in 2009 to that in 2011?
Your answer should be compact. 1. What is the ratio of the Rating (1=low 6=high) of East Asia (developing only) in 2009 to that in 2012?
Ensure brevity in your answer.  1.02. What is the ratio of the Rating (1=low 6=high) of Fragile and conflict affected situations in 2009 to that in 2012?
Make the answer very short. 1.01. What is the ratio of the Rating (1=low 6=high) in Pacific island small states in 2009 to that in 2012?
Provide a succinct answer. 1.03. What is the ratio of the Rating (1=low 6=high) of East Asia (developing only) in 2009 to that in 2013?
Offer a terse response. 1.02. What is the ratio of the Rating (1=low 6=high) of Tonga in 2009 to that in 2013?
Ensure brevity in your answer.  1. What is the ratio of the Rating (1=low 6=high) of East Asia (developing only) in 2009 to that in 2014?
Provide a short and direct response. 1.02. What is the ratio of the Rating (1=low 6=high) in Fragile and conflict affected situations in 2009 to that in 2014?
Offer a very short reply. 1.01. What is the ratio of the Rating (1=low 6=high) in East Asia (developing only) in 2010 to that in 2011?
Your answer should be compact. 1.02. What is the ratio of the Rating (1=low 6=high) in Fragile and conflict affected situations in 2010 to that in 2011?
Keep it short and to the point. 1.01. What is the ratio of the Rating (1=low 6=high) of Pacific island small states in 2010 to that in 2011?
Keep it short and to the point. 1.03. What is the ratio of the Rating (1=low 6=high) of East Asia (developing only) in 2010 to that in 2012?
Keep it short and to the point. 1.02. What is the ratio of the Rating (1=low 6=high) of Fragile and conflict affected situations in 2010 to that in 2012?
Your answer should be compact. 1.02. What is the ratio of the Rating (1=low 6=high) of Pacific island small states in 2010 to that in 2012?
Your answer should be compact. 1.03. What is the ratio of the Rating (1=low 6=high) in Tonga in 2010 to that in 2012?
Your answer should be compact. 1. What is the ratio of the Rating (1=low 6=high) in East Asia (developing only) in 2010 to that in 2013?
Provide a short and direct response. 1.02. What is the ratio of the Rating (1=low 6=high) in Fragile and conflict affected situations in 2010 to that in 2013?
Keep it short and to the point. 1.02. What is the ratio of the Rating (1=low 6=high) of East Asia (developing only) in 2010 to that in 2014?
Provide a succinct answer. 1.02. What is the ratio of the Rating (1=low 6=high) in Fragile and conflict affected situations in 2010 to that in 2014?
Provide a short and direct response. 1.02. What is the ratio of the Rating (1=low 6=high) in Pacific island small states in 2010 to that in 2014?
Your answer should be very brief. 1.03. What is the ratio of the Rating (1=low 6=high) of Tonga in 2010 to that in 2014?
Keep it short and to the point. 1. What is the ratio of the Rating (1=low 6=high) in East Asia (developing only) in 2011 to that in 2012?
Make the answer very short. 1.01. What is the ratio of the Rating (1=low 6=high) of Fragile and conflict affected situations in 2011 to that in 2012?
Ensure brevity in your answer.  1.01. What is the ratio of the Rating (1=low 6=high) in Pacific island small states in 2011 to that in 2012?
Offer a very short reply. 1. What is the ratio of the Rating (1=low 6=high) of East Asia (developing only) in 2011 to that in 2013?
Offer a terse response. 1. What is the ratio of the Rating (1=low 6=high) of Fragile and conflict affected situations in 2011 to that in 2013?
Provide a short and direct response. 1.01. What is the ratio of the Rating (1=low 6=high) of Tonga in 2011 to that in 2013?
Keep it short and to the point. 1. What is the ratio of the Rating (1=low 6=high) of East Asia (developing only) in 2011 to that in 2014?
Offer a very short reply. 1. What is the ratio of the Rating (1=low 6=high) of Fragile and conflict affected situations in 2011 to that in 2014?
Give a very brief answer. 1.01. What is the ratio of the Rating (1=low 6=high) in Pacific island small states in 2011 to that in 2014?
Offer a very short reply. 1. What is the ratio of the Rating (1=low 6=high) in East Asia (developing only) in 2012 to that in 2013?
Your answer should be very brief. 1. What is the ratio of the Rating (1=low 6=high) of Pacific island small states in 2012 to that in 2013?
Your answer should be very brief. 1. What is the ratio of the Rating (1=low 6=high) of Pacific island small states in 2012 to that in 2014?
Your answer should be compact. 1. What is the ratio of the Rating (1=low 6=high) of East Asia (developing only) in 2013 to that in 2014?
Offer a very short reply. 1. What is the ratio of the Rating (1=low 6=high) in Pacific island small states in 2013 to that in 2014?
Make the answer very short. 1. What is the ratio of the Rating (1=low 6=high) of Tonga in 2013 to that in 2014?
Provide a succinct answer. 1. What is the difference between the highest and the second highest Rating (1=low 6=high) in East Asia (developing only)?
Give a very brief answer. 0. What is the difference between the highest and the second highest Rating (1=low 6=high) in Fragile and conflict affected situations?
Make the answer very short. 0.02. What is the difference between the highest and the lowest Rating (1=low 6=high) of East Asia (developing only)?
Make the answer very short. 0.08. What is the difference between the highest and the lowest Rating (1=low 6=high) of Fragile and conflict affected situations?
Keep it short and to the point. 0.07. What is the difference between the highest and the lowest Rating (1=low 6=high) in Pacific island small states?
Provide a short and direct response. 0.1. 